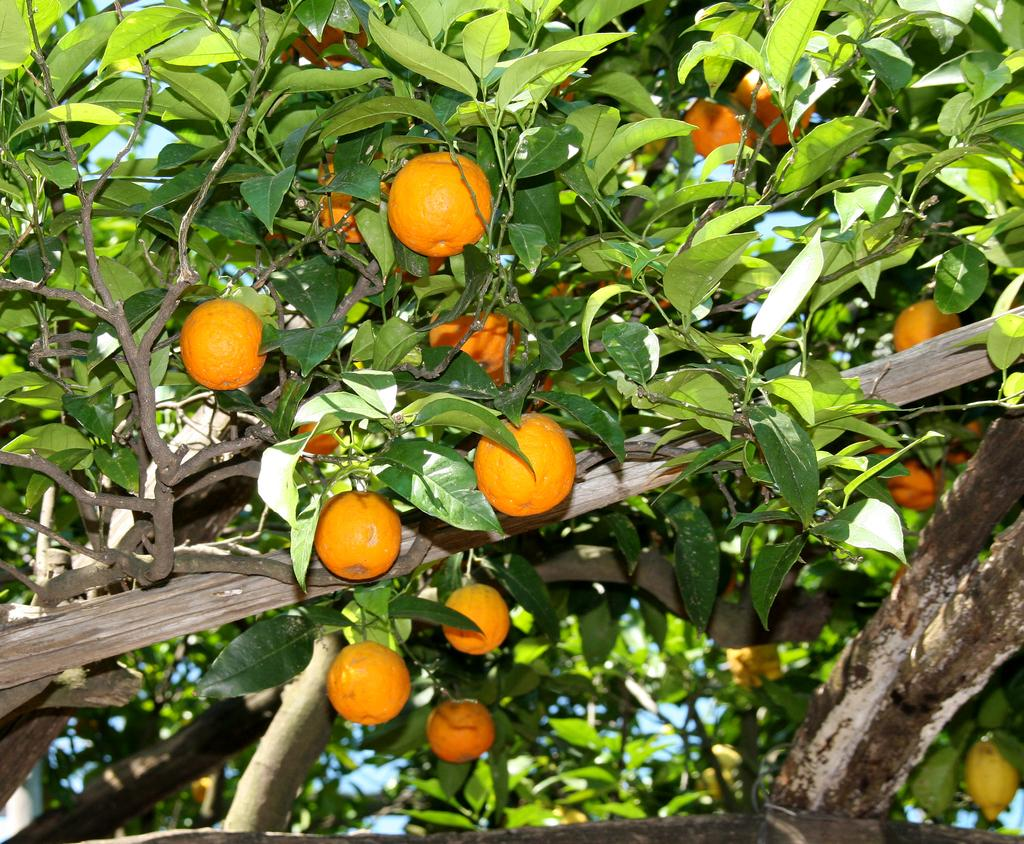What type of fruit can be seen on the tree in the image? There are oranges on a tree in the image. What else can be seen on the tree besides the fruit? Leaves are visible in the image. What part of the tree can be seen supporting the fruit and leaves? Branches are visible in the image. What type of joke is being told by the rod in the image? There is no rod present in the image, and therefore no joke can be told by it. 